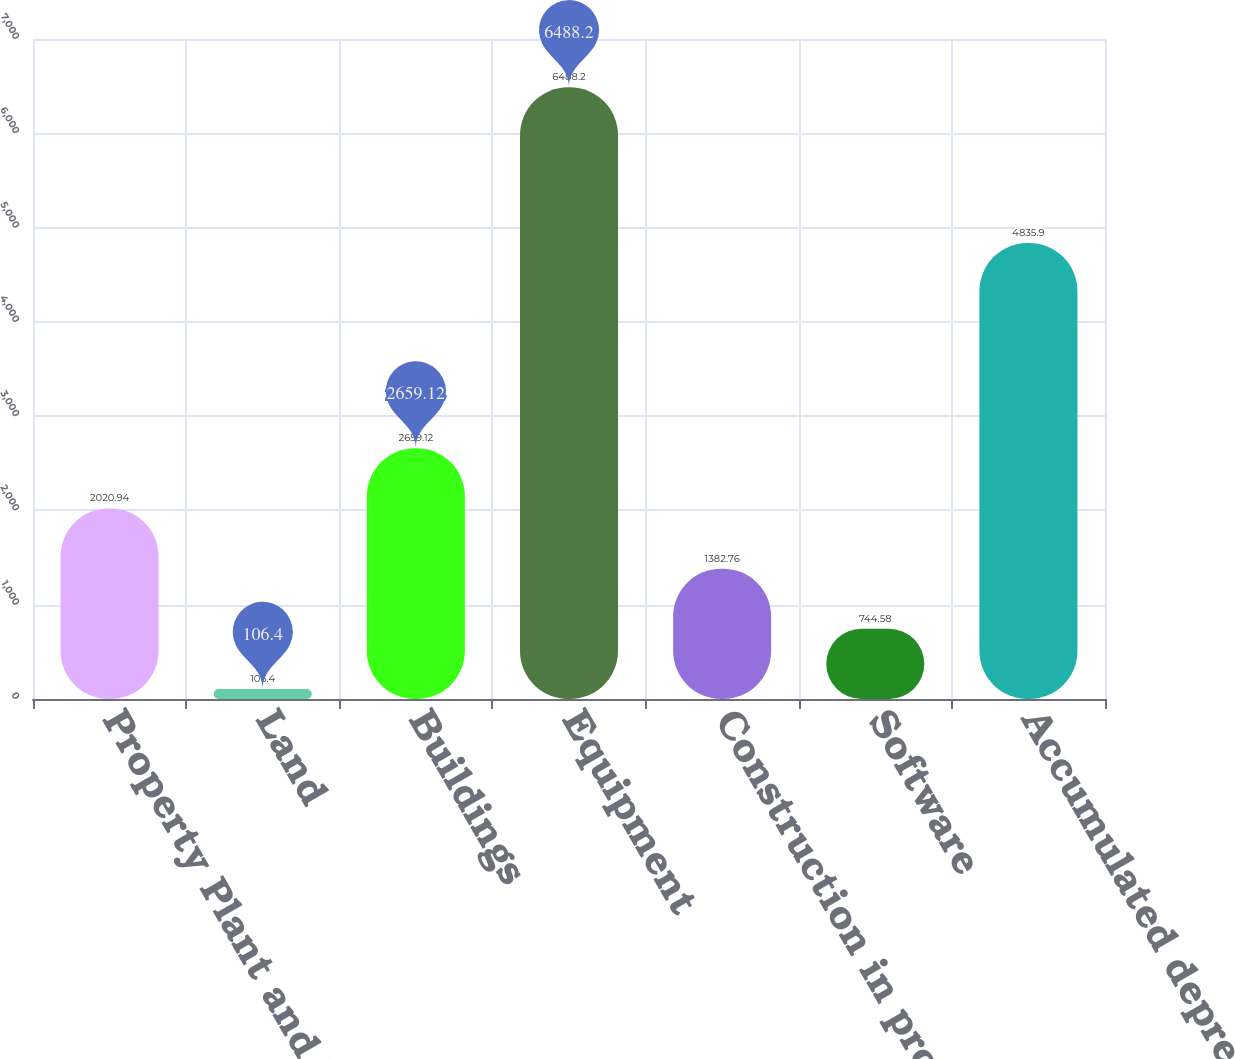Convert chart. <chart><loc_0><loc_0><loc_500><loc_500><bar_chart><fcel>Property Plant and Equipment<fcel>Land<fcel>Buildings<fcel>Equipment<fcel>Construction in progress<fcel>Software<fcel>Accumulated depreciation<nl><fcel>2020.94<fcel>106.4<fcel>2659.12<fcel>6488.2<fcel>1382.76<fcel>744.58<fcel>4835.9<nl></chart> 